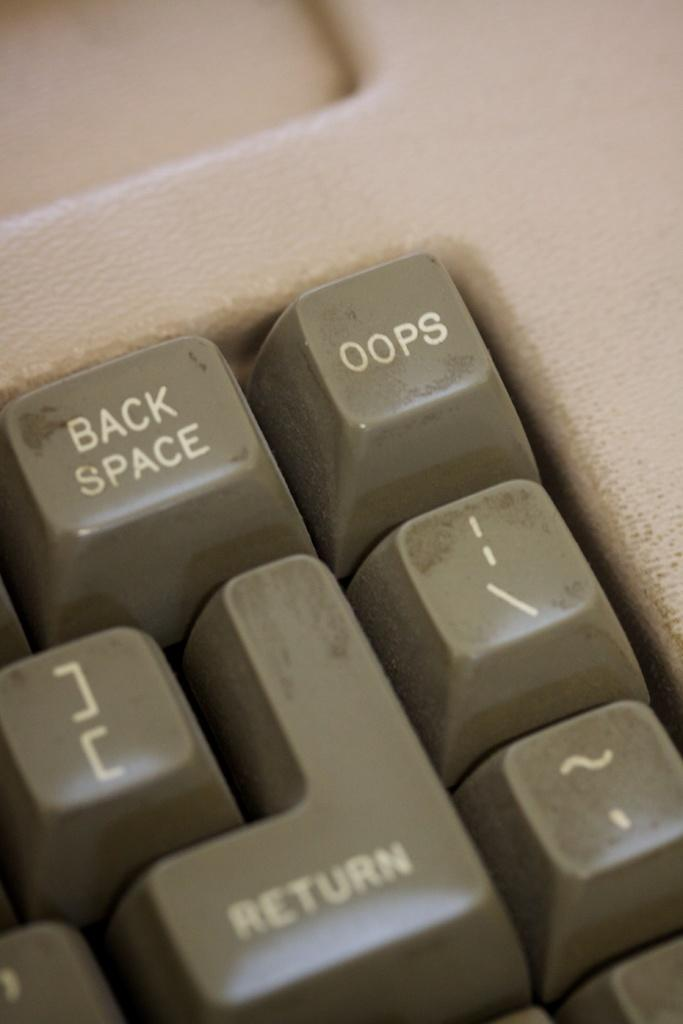<image>
Give a short and clear explanation of the subsequent image. The top right corner of an old keyboard with a backspace and oops button. 